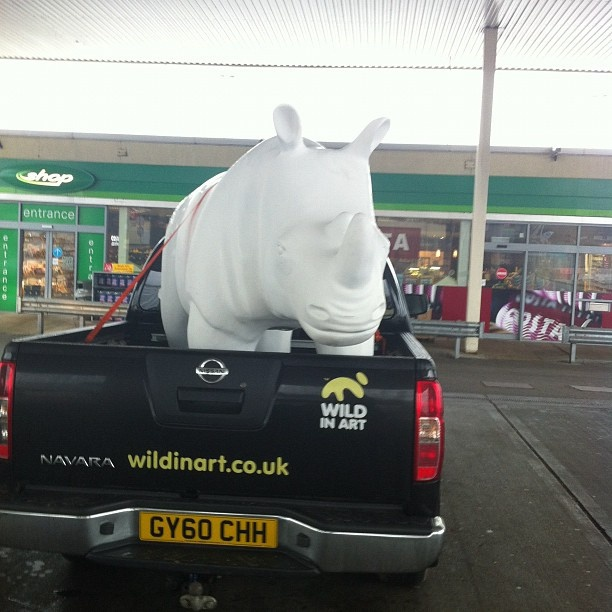Describe the objects in this image and their specific colors. I can see truck in darkgray, black, gray, and olive tones and bench in darkgray and gray tones in this image. 